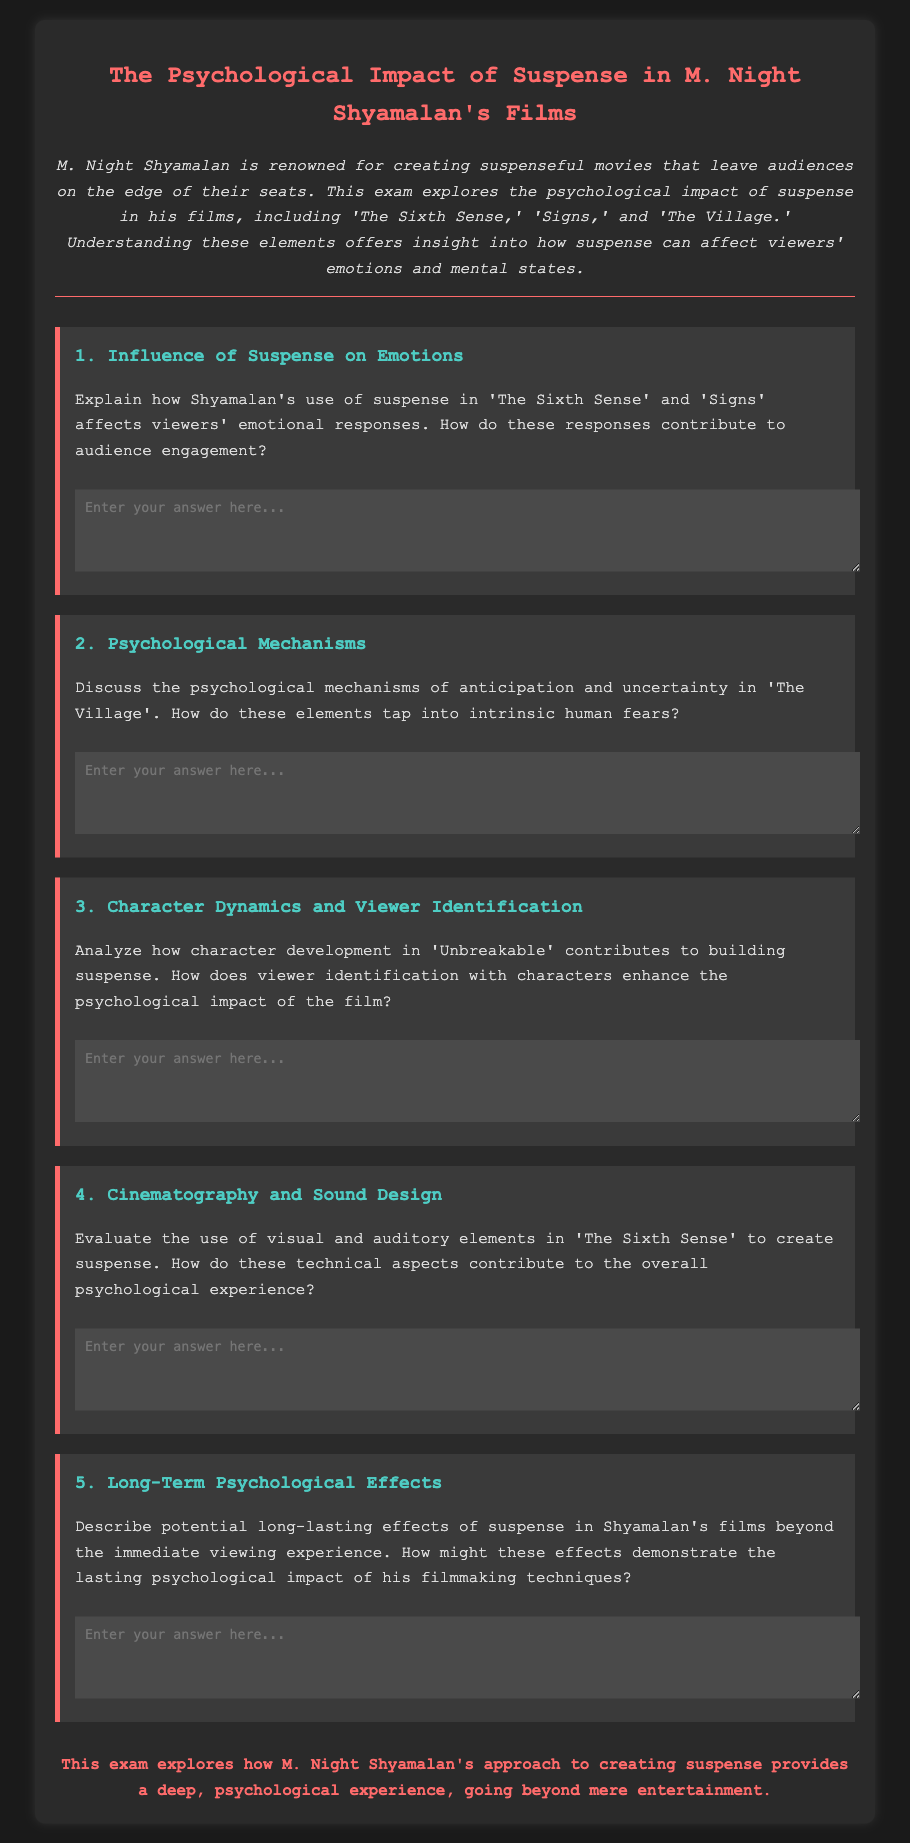What is the title of the exam? The title of the exam is found in the header section of the document.
Answer: The Psychological Impact of Suspense in M. Night Shyamalan's Films How many questions are included in the exam? The exam consists of five distinct questions as outlined in the document.
Answer: 5 In which films does the document mention Shyamalan's creation of suspense? The films referenced in discussing suspense are located in the introductory section of the document.
Answer: The Sixth Sense, Signs, The Village, Unbreakable What color is used for the title of the exam? The color of the title is described in the style section of the document.
Answer: #ff6b6b What psychological elements does the second question focus on? The second question specifically addresses psychological mechanisms as stated in the document.
Answer: Anticipation and uncertainty What does the conclusion emphasize about Shyamalan's films? The conclusion summarizes the overall focus on psychological experience in relation to Shyamalan's work.
Answer: Deep, psychological experience Which film is analyzed for character dynamics in building suspense? The film highlighted for character dynamics is mentioned in the third question of the document.
Answer: Unbreakable What is the background color of the document? The overall background color is provided in the style section of the document.
Answer: #1a1a1a 